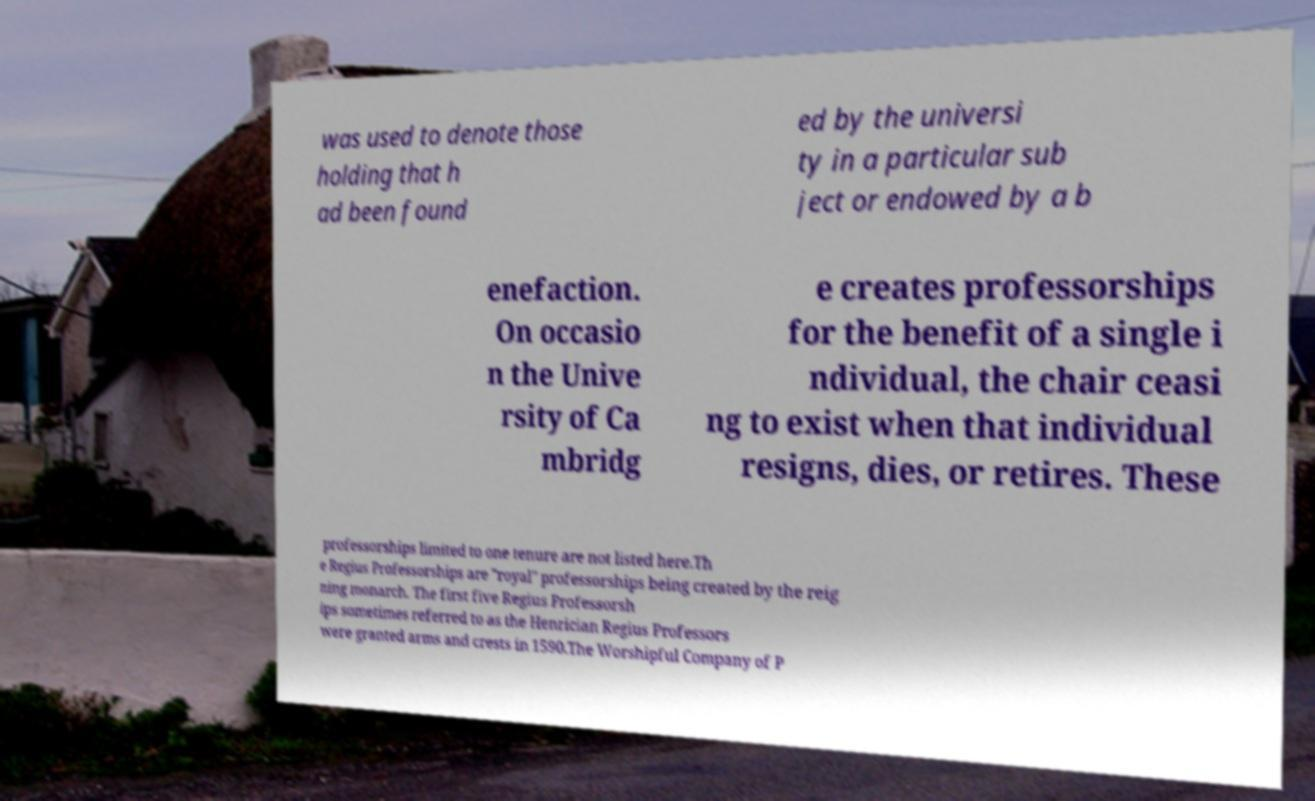Please identify and transcribe the text found in this image. was used to denote those holding that h ad been found ed by the universi ty in a particular sub ject or endowed by a b enefaction. On occasio n the Unive rsity of Ca mbridg e creates professorships for the benefit of a single i ndividual, the chair ceasi ng to exist when that individual resigns, dies, or retires. These professorships limited to one tenure are not listed here.Th e Regius Professorships are "royal" professorships being created by the reig ning monarch. The first five Regius Professorsh ips sometimes referred to as the Henrician Regius Professors were granted arms and crests in 1590.The Worshipful Company of P 